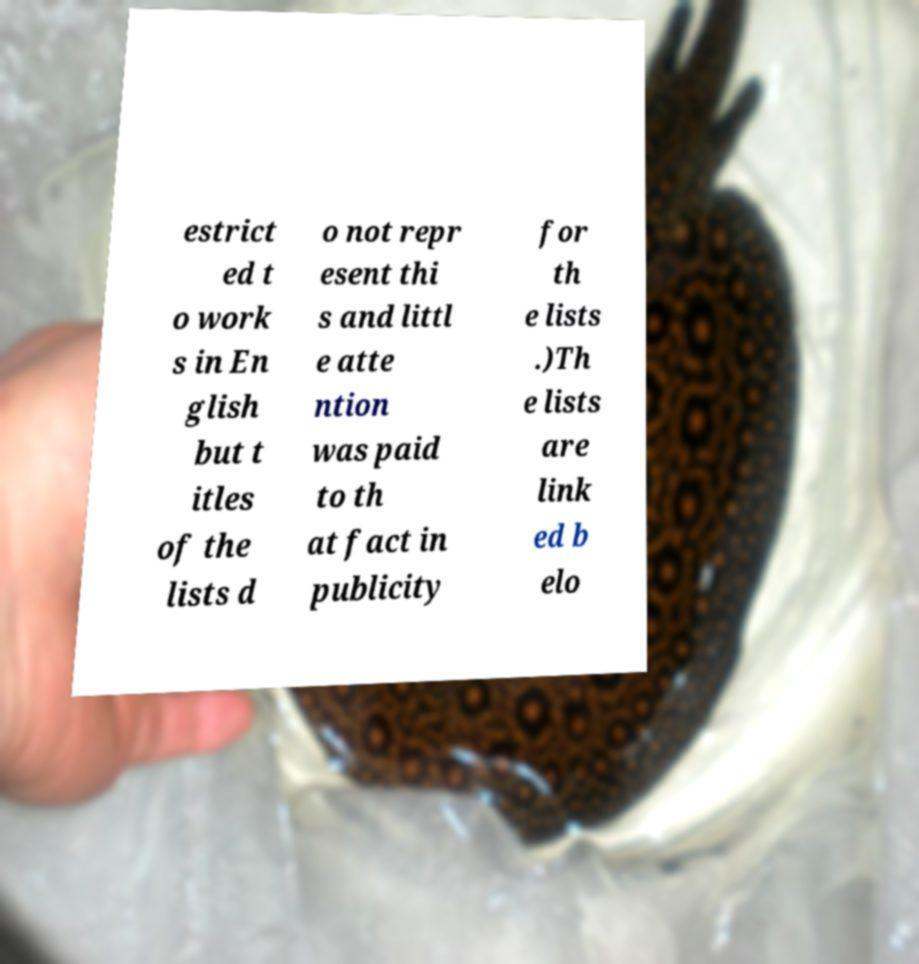There's text embedded in this image that I need extracted. Can you transcribe it verbatim? estrict ed t o work s in En glish but t itles of the lists d o not repr esent thi s and littl e atte ntion was paid to th at fact in publicity for th e lists .)Th e lists are link ed b elo 